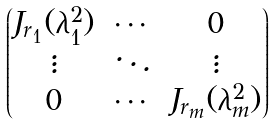<formula> <loc_0><loc_0><loc_500><loc_500>\begin{pmatrix} J _ { r _ { 1 } } ( \lambda _ { 1 } ^ { 2 } ) & \cdots & 0 \\ \vdots & \ddots & \vdots \\ 0 & \cdots & J _ { r _ { m } } ( \lambda _ { m } ^ { 2 } ) \end{pmatrix}</formula> 